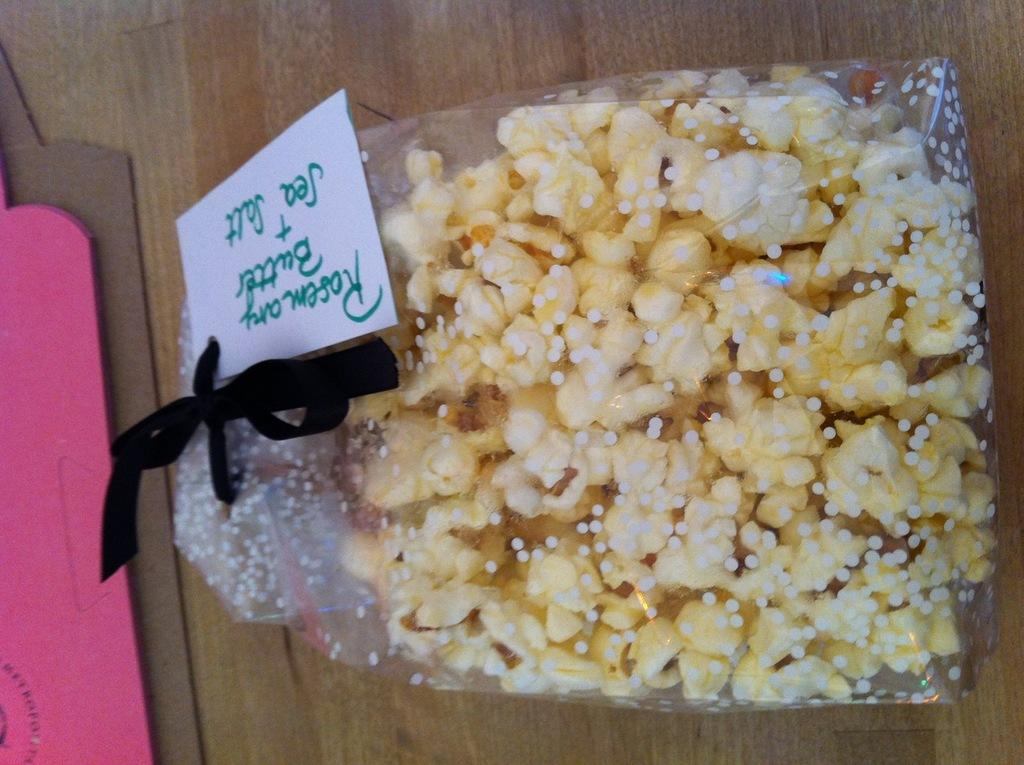What is the color of the surface in the image? The surface in the image is brown colored. What is the color of the object on the surface? There is a pink colored object on the surface. What can be found in the packet in the image? The packet contains popcorn. What is attached to the packet in the image? There is a white colored board attached to the packet. Can you see a horse running on the brown surface in the image? No, there is no horse present in the image; it only features a pink object, a packet with popcorn, and a white colored board attached to the packet. 